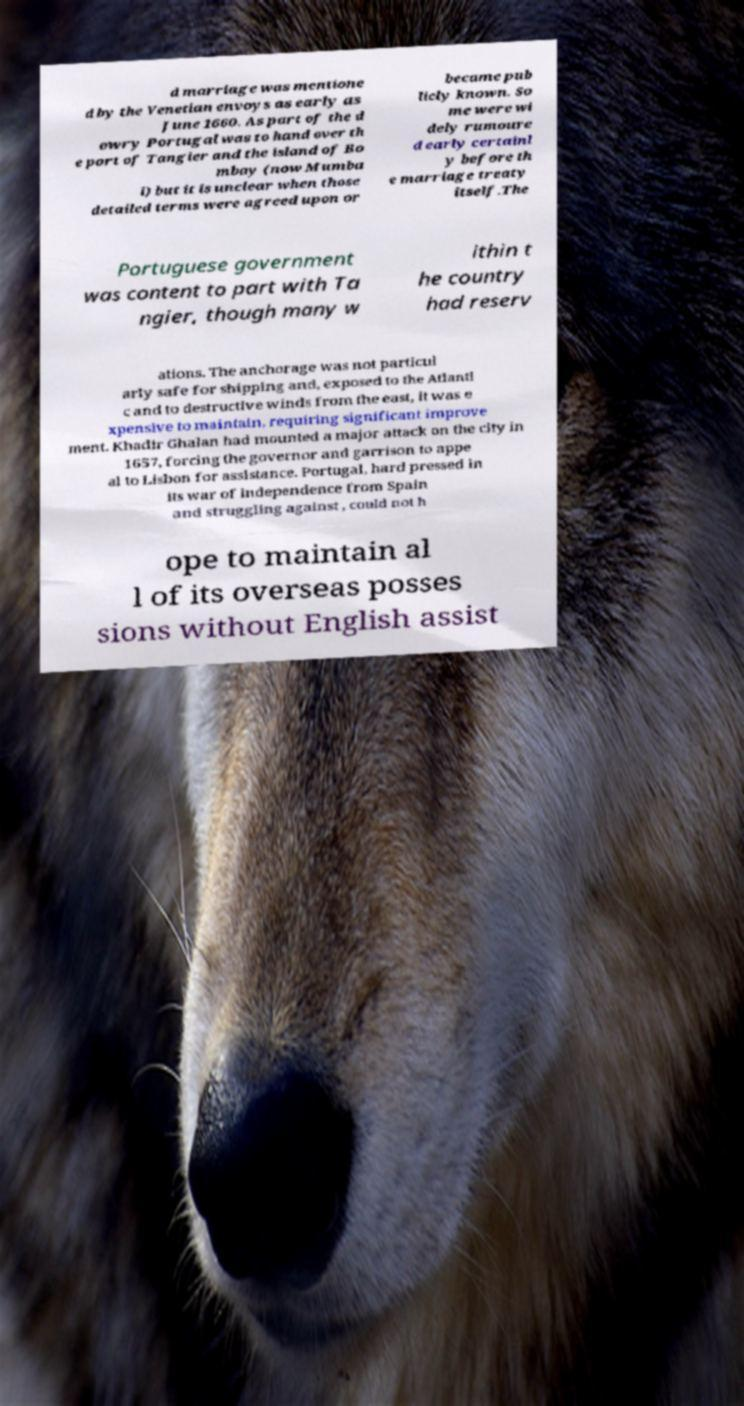I need the written content from this picture converted into text. Can you do that? d marriage was mentione d by the Venetian envoys as early as June 1660. As part of the d owry Portugal was to hand over th e port of Tangier and the island of Bo mbay (now Mumba i) but it is unclear when those detailed terms were agreed upon or became pub licly known. So me were wi dely rumoure d early certainl y before th e marriage treaty itself.The Portuguese government was content to part with Ta ngier, though many w ithin t he country had reserv ations. The anchorage was not particul arly safe for shipping and, exposed to the Atlanti c and to destructive winds from the east, it was e xpensive to maintain, requiring significant improve ment. Khadir Ghalan had mounted a major attack on the city in 1657, forcing the governor and garrison to appe al to Lisbon for assistance. Portugal, hard pressed in its war of independence from Spain and struggling against , could not h ope to maintain al l of its overseas posses sions without English assist 